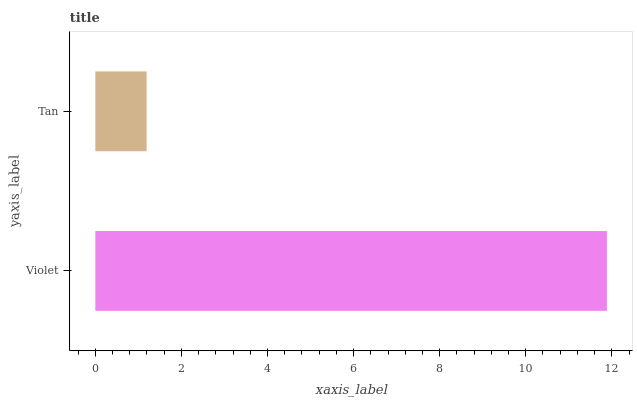Is Tan the minimum?
Answer yes or no. Yes. Is Violet the maximum?
Answer yes or no. Yes. Is Tan the maximum?
Answer yes or no. No. Is Violet greater than Tan?
Answer yes or no. Yes. Is Tan less than Violet?
Answer yes or no. Yes. Is Tan greater than Violet?
Answer yes or no. No. Is Violet less than Tan?
Answer yes or no. No. Is Violet the high median?
Answer yes or no. Yes. Is Tan the low median?
Answer yes or no. Yes. Is Tan the high median?
Answer yes or no. No. Is Violet the low median?
Answer yes or no. No. 